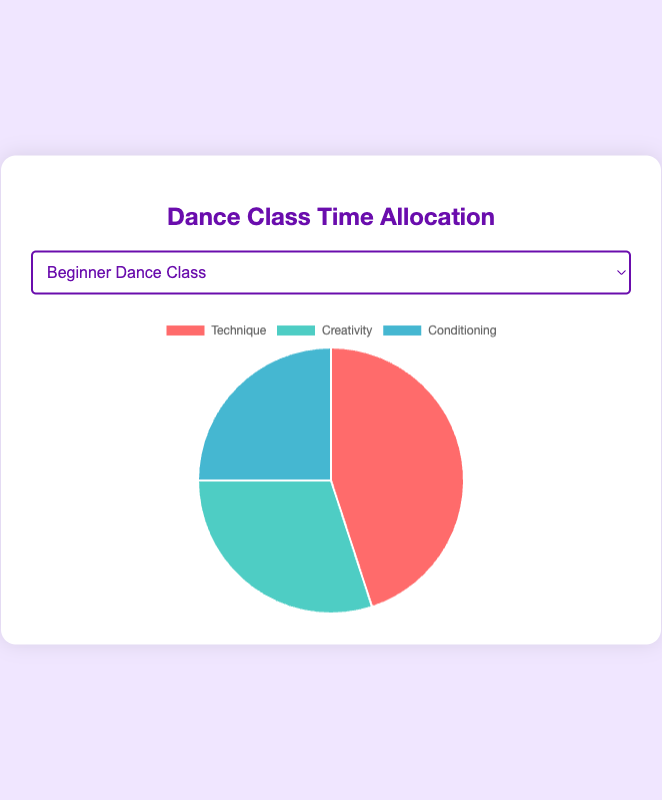Which class allocates the most time to Technique? Looking at the pie charts for each class, the Advanced Dance Class has the highest percentage for Technique, which is 60%.
Answer: Advanced Dance Class Among the classes, which one dedicates the least amount of time to Creativity? The pie charts show that the Advanced Dance Class allocates 25% of its time to Creativity, which is the least amount compared to other classes.
Answer: Advanced Dance Class Which types of dance classes have an equal percentage of Conditioning allocation? Observing the pie charts, both the Advanced Dance Class and the Intermediate Dance Class allocate 15% of their time to Conditioning.
Answer: Advanced Dance Class, Intermediate Dance Class By how much does the time allocated to Creativity in the Choreography Intensive class exceed that in the Beginner Dance Class? The Choreography Intensive class allocates 40% to Creativity, while the Beginner Dance Class allocates 30%. The difference is 40% - 30% = 10%.
Answer: 10% Is the total time allocated to Conditioning in the Contemporary Dance Workshop greater than the time allocated to Creativity in the Advanced Dance Class? The Contemporary Dance Workshop allocates 20% to Conditioning, and the Advanced Dance Class allocates 25% to Creativity. 20% is less than 25%.
Answer: No Which class has the most balanced time allocation across Technique, Creativity, and Conditioning? Looking at the pie charts, the Beginner Dance Class has the most balanced distribution: 45% Technique, 30% Creativity, and 25% Conditioning. Each component is close to being equal in distribution.
Answer: Beginner Dance Class By what percentage is the Technique allocation higher in the Advanced Dance Class than in the Intermediate Dance Class? The Advanced Dance Class allocates 60% to Technique whereas the Intermediate Dance Class allocates 50%. The difference is 60% - 50% = 10%.
Answer: 10% Considering Technique alone, how much more time is spent in the Contemporary Dance Workshop compared to the Choreography Intensive? The Contemporary Dance Workshop dedicates 50% to Technique, while the Choreography Intensive dedicates 40%. The difference is 50% - 40% = 10%.
Answer: 10% 